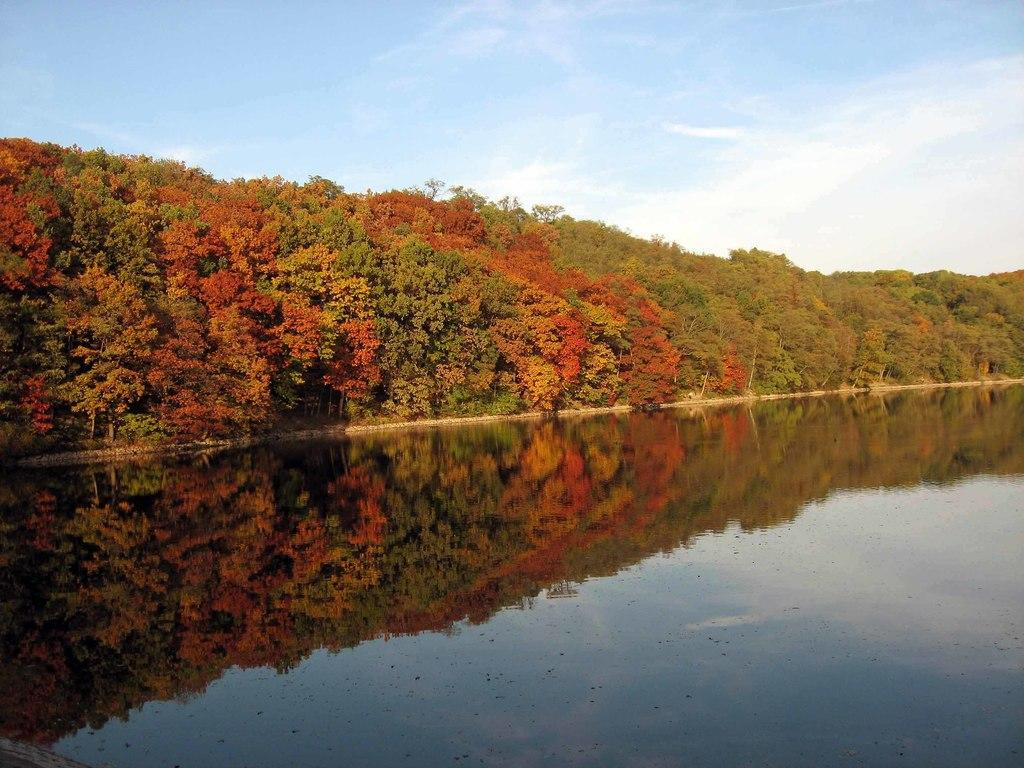What is the primary element in the image? There is water in the image. What colors can be seen on the trees in the image? The trees have green, red, and orange colors in the image. What can be seen in the background of the image? The sky is visible in the background of the image, and clouds are present. Is there a match being used to light a fire in the image? There is no match or fire present in the image. Is there a person wearing a scarf in the image? There is no person or scarf present in the image. 